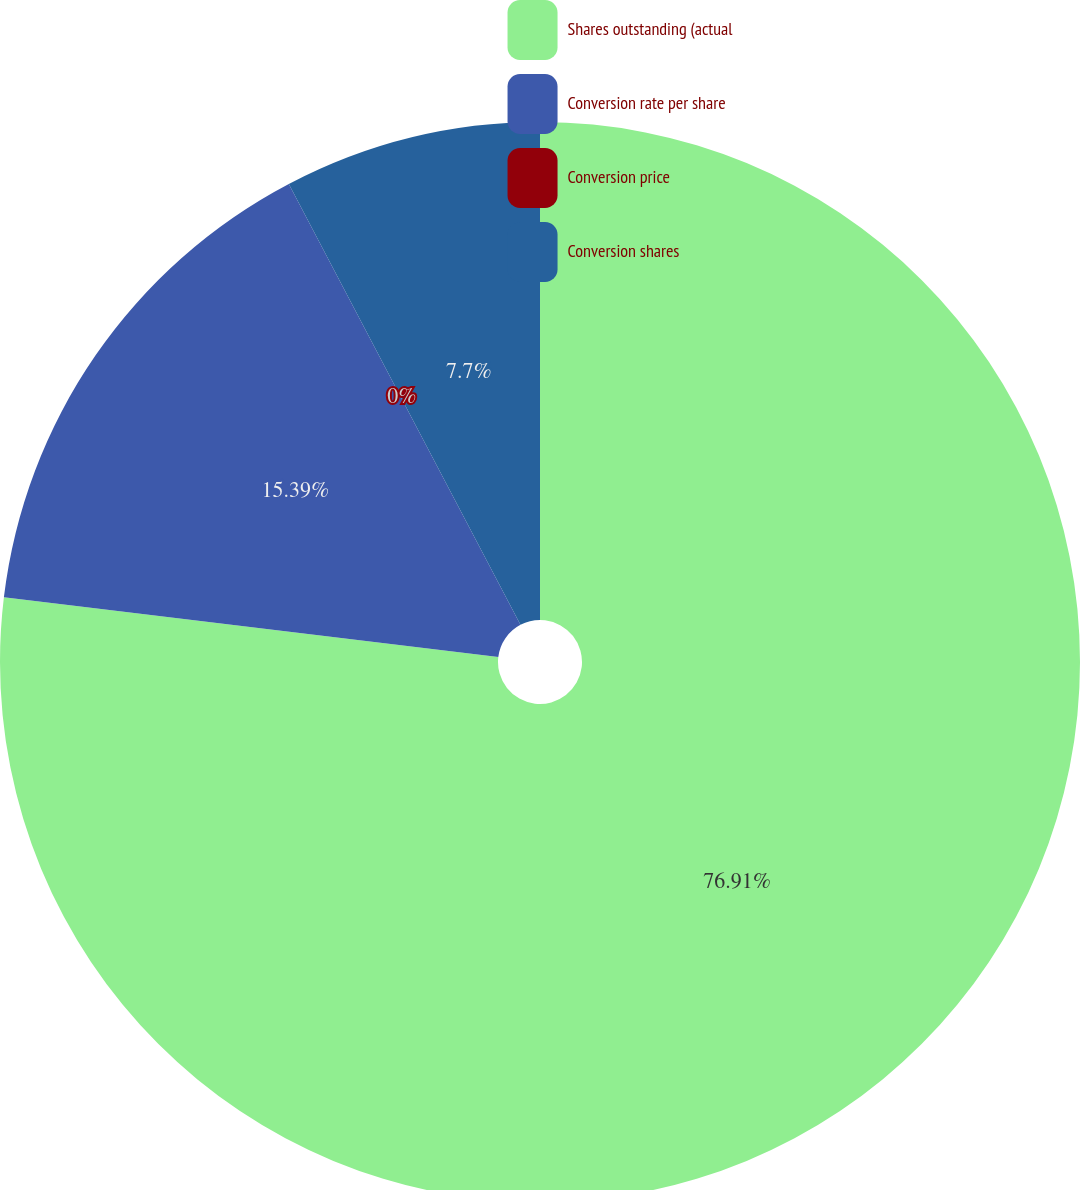Convert chart to OTSL. <chart><loc_0><loc_0><loc_500><loc_500><pie_chart><fcel>Shares outstanding (actual<fcel>Conversion rate per share<fcel>Conversion price<fcel>Conversion shares<nl><fcel>76.91%<fcel>15.39%<fcel>0.0%<fcel>7.7%<nl></chart> 